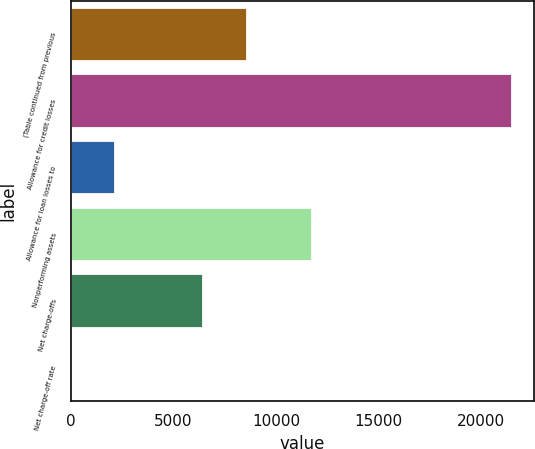Convert chart. <chart><loc_0><loc_0><loc_500><loc_500><bar_chart><fcel>(Table continued from previous<fcel>Allowance for credit losses<fcel>Allowance for loan losses to<fcel>Nonperforming assets<fcel>Net charge-offs<fcel>Net charge-off rate<nl><fcel>8598.97<fcel>21496<fcel>2150.47<fcel>11739<fcel>6449.47<fcel>0.97<nl></chart> 